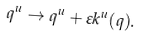Convert formula to latex. <formula><loc_0><loc_0><loc_500><loc_500>q ^ { u } \rightarrow q ^ { u } + \varepsilon k ^ { u } ( q ) .</formula> 